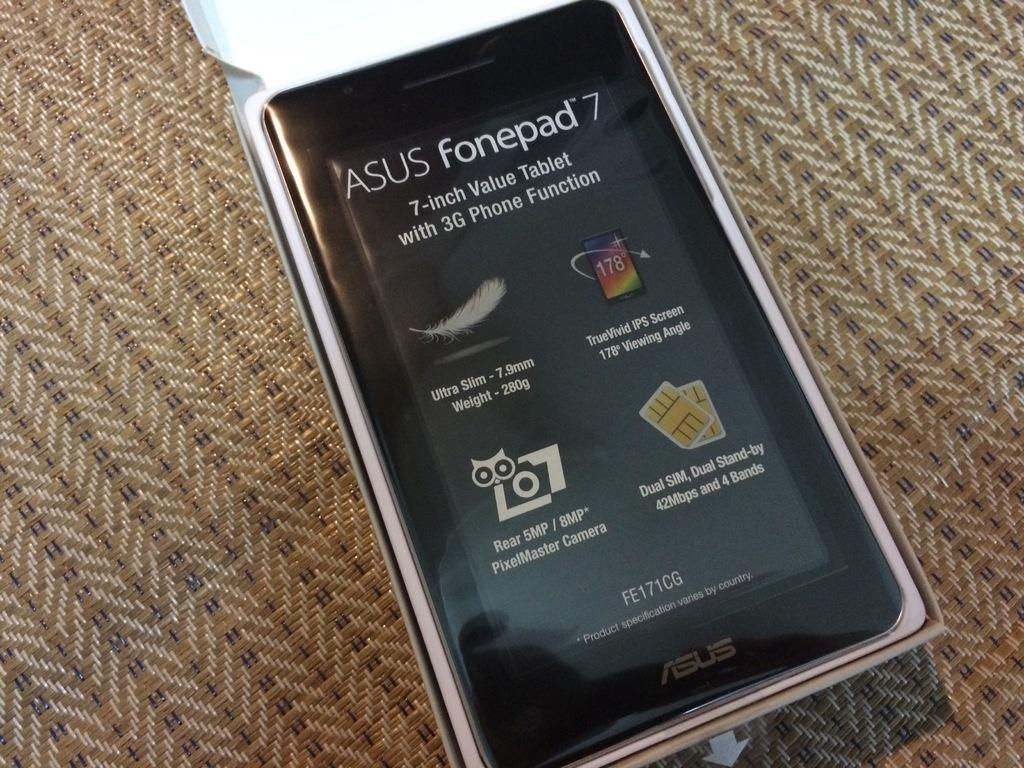<image>
Write a terse but informative summary of the picture. an asus fonepade that is sitting on a cushion material 